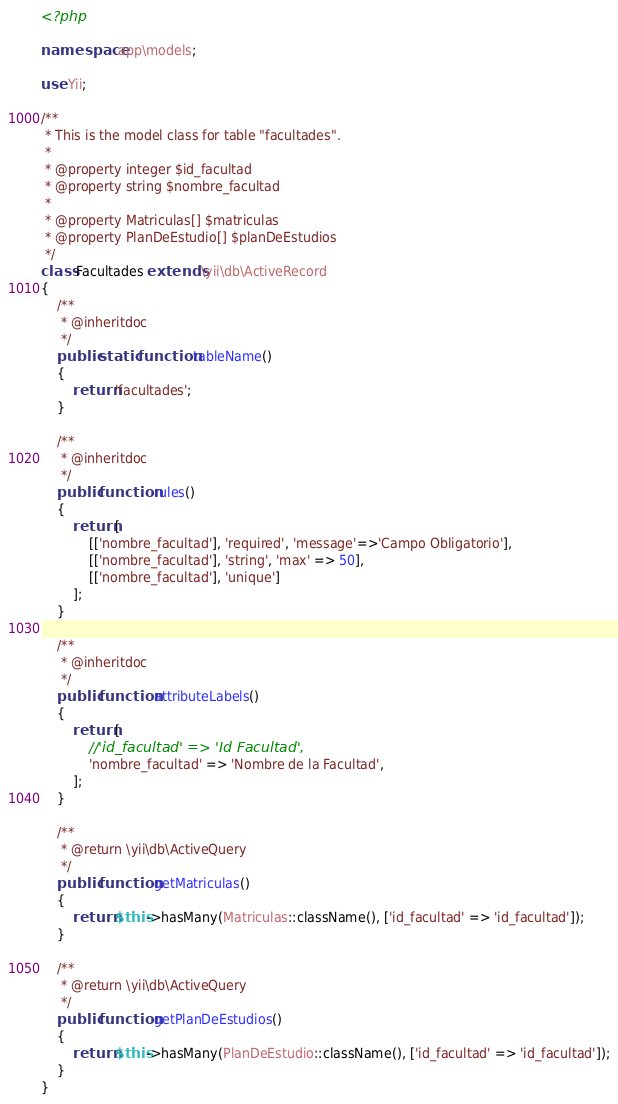Convert code to text. <code><loc_0><loc_0><loc_500><loc_500><_PHP_><?php

namespace app\models;

use Yii;

/**
 * This is the model class for table "facultades".
 *
 * @property integer $id_facultad
 * @property string $nombre_facultad
 *
 * @property Matriculas[] $matriculas
 * @property PlanDeEstudio[] $planDeEstudios
 */
class Facultades extends \yii\db\ActiveRecord
{
    /**
     * @inheritdoc
     */
    public static function tableName()
    {
        return 'facultades';
    }

    /**
     * @inheritdoc
     */
    public function rules()
    {
        return [
            [['nombre_facultad'], 'required', 'message'=>'Campo Obligatorio'],
            [['nombre_facultad'], 'string', 'max' => 50],
            [['nombre_facultad'], 'unique']
        ];
    }

    /**
     * @inheritdoc
     */
    public function attributeLabels()
    {
        return [
            //'id_facultad' => 'Id Facultad',
            'nombre_facultad' => 'Nombre de la Facultad',
        ];
    }

    /**
     * @return \yii\db\ActiveQuery
     */
    public function getMatriculas()
    {
        return $this->hasMany(Matriculas::className(), ['id_facultad' => 'id_facultad']);
    }

    /**
     * @return \yii\db\ActiveQuery
     */
    public function getPlanDeEstudios()
    {
        return $this->hasMany(PlanDeEstudio::className(), ['id_facultad' => 'id_facultad']);
    }
}
</code> 